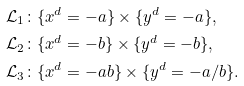<formula> <loc_0><loc_0><loc_500><loc_500>\mathcal { L } _ { 1 } & \colon \{ x ^ { d } = - a \} \times \{ y ^ { d } = - a \} , \\ \mathcal { L } _ { 2 } & \colon \{ x ^ { d } = - b \} \times \{ y ^ { d } = - b \} , \\ \mathcal { L } _ { 3 } & \colon \{ x ^ { d } = - a b \} \times \{ y ^ { d } = - a / b \} .</formula> 